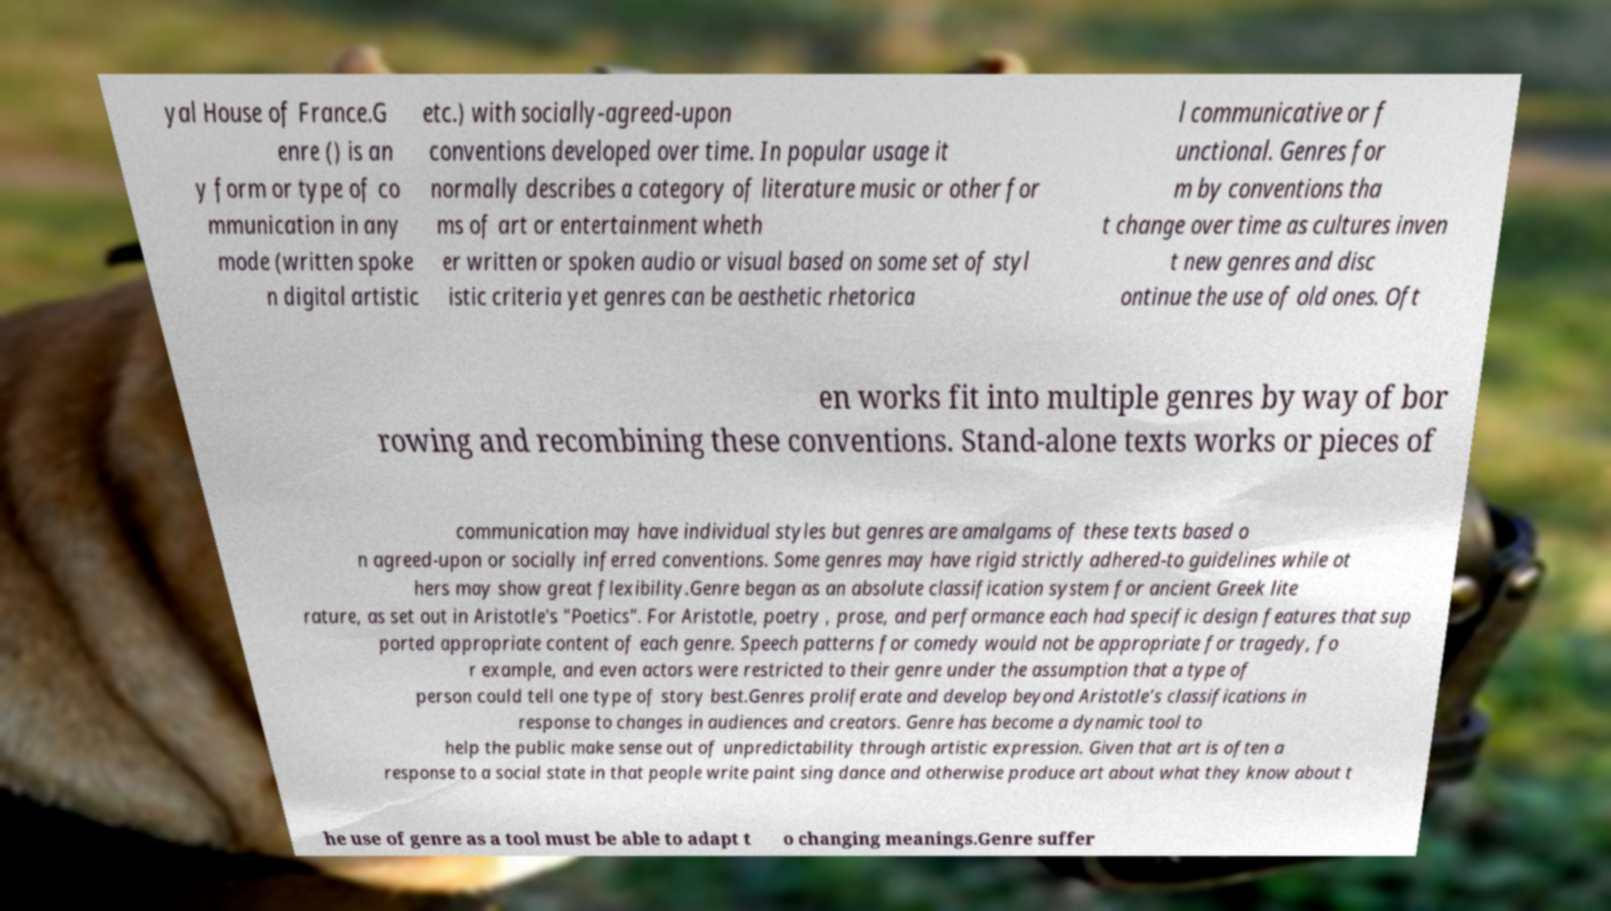Please read and relay the text visible in this image. What does it say? yal House of France.G enre () is an y form or type of co mmunication in any mode (written spoke n digital artistic etc.) with socially-agreed-upon conventions developed over time. In popular usage it normally describes a category of literature music or other for ms of art or entertainment wheth er written or spoken audio or visual based on some set of styl istic criteria yet genres can be aesthetic rhetorica l communicative or f unctional. Genres for m by conventions tha t change over time as cultures inven t new genres and disc ontinue the use of old ones. Oft en works fit into multiple genres by way of bor rowing and recombining these conventions. Stand-alone texts works or pieces of communication may have individual styles but genres are amalgams of these texts based o n agreed-upon or socially inferred conventions. Some genres may have rigid strictly adhered-to guidelines while ot hers may show great flexibility.Genre began as an absolute classification system for ancient Greek lite rature, as set out in Aristotle's "Poetics". For Aristotle, poetry , prose, and performance each had specific design features that sup ported appropriate content of each genre. Speech patterns for comedy would not be appropriate for tragedy, fo r example, and even actors were restricted to their genre under the assumption that a type of person could tell one type of story best.Genres proliferate and develop beyond Aristotle’s classifications in response to changes in audiences and creators. Genre has become a dynamic tool to help the public make sense out of unpredictability through artistic expression. Given that art is often a response to a social state in that people write paint sing dance and otherwise produce art about what they know about t he use of genre as a tool must be able to adapt t o changing meanings.Genre suffer 